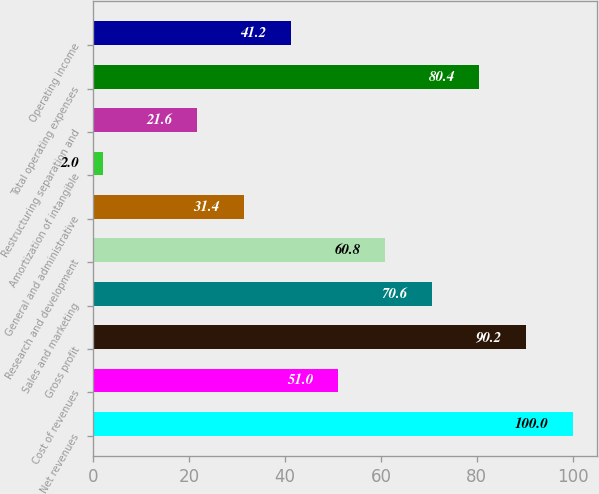Convert chart. <chart><loc_0><loc_0><loc_500><loc_500><bar_chart><fcel>Net revenues<fcel>Cost of revenues<fcel>Gross profit<fcel>Sales and marketing<fcel>Research and development<fcel>General and administrative<fcel>Amortization of intangible<fcel>Restructuring separation and<fcel>Total operating expenses<fcel>Operating income<nl><fcel>100<fcel>51<fcel>90.2<fcel>70.6<fcel>60.8<fcel>31.4<fcel>2<fcel>21.6<fcel>80.4<fcel>41.2<nl></chart> 